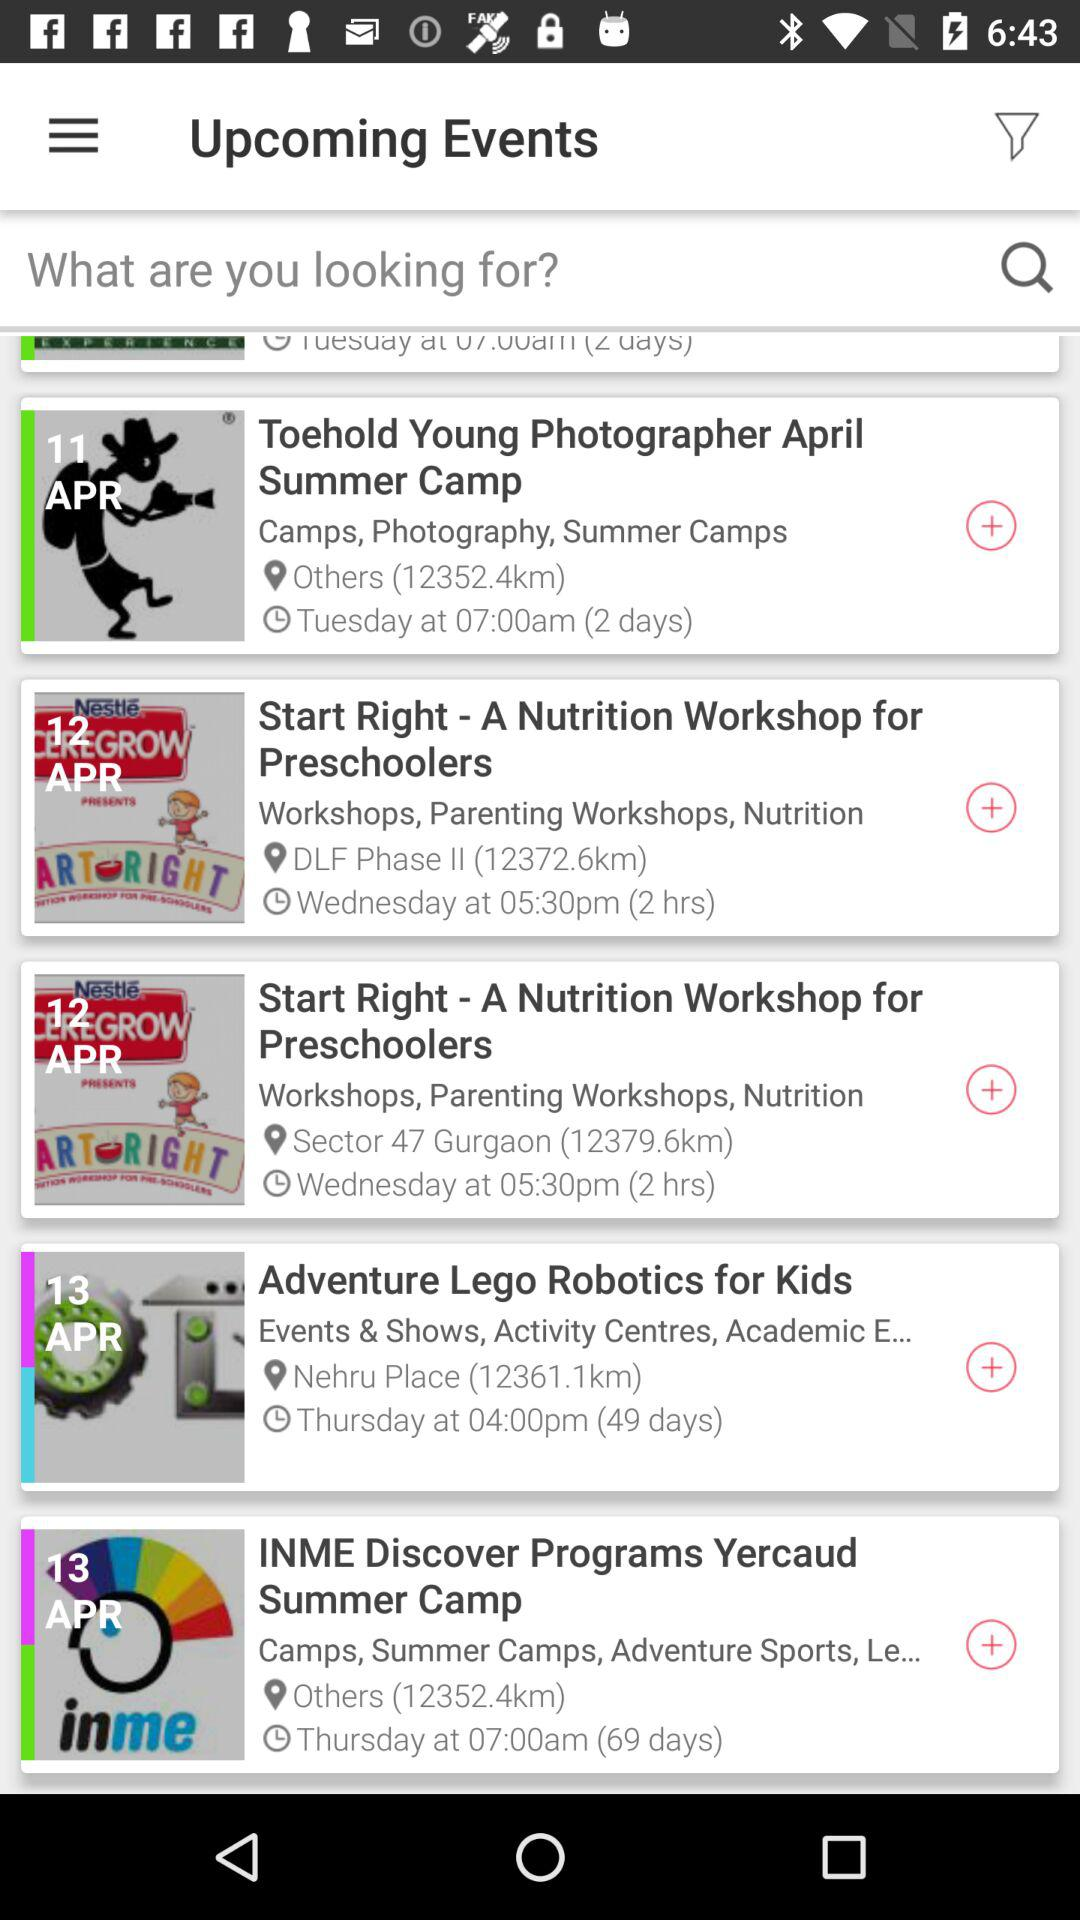What day is "Adventure Lego Robotics for Kids"? The day is Thursday. 